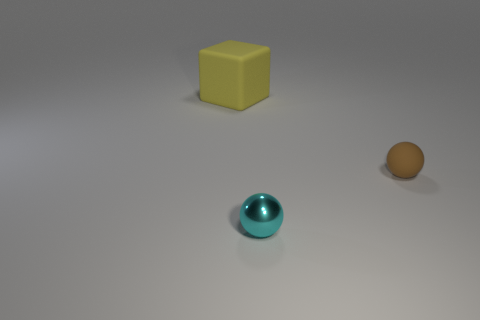Add 1 big blocks. How many objects exist? 4 Subtract all balls. How many objects are left? 1 Subtract all small metal objects. Subtract all small shiny things. How many objects are left? 1 Add 2 cyan spheres. How many cyan spheres are left? 3 Add 2 small brown matte balls. How many small brown matte balls exist? 3 Subtract 0 red balls. How many objects are left? 3 